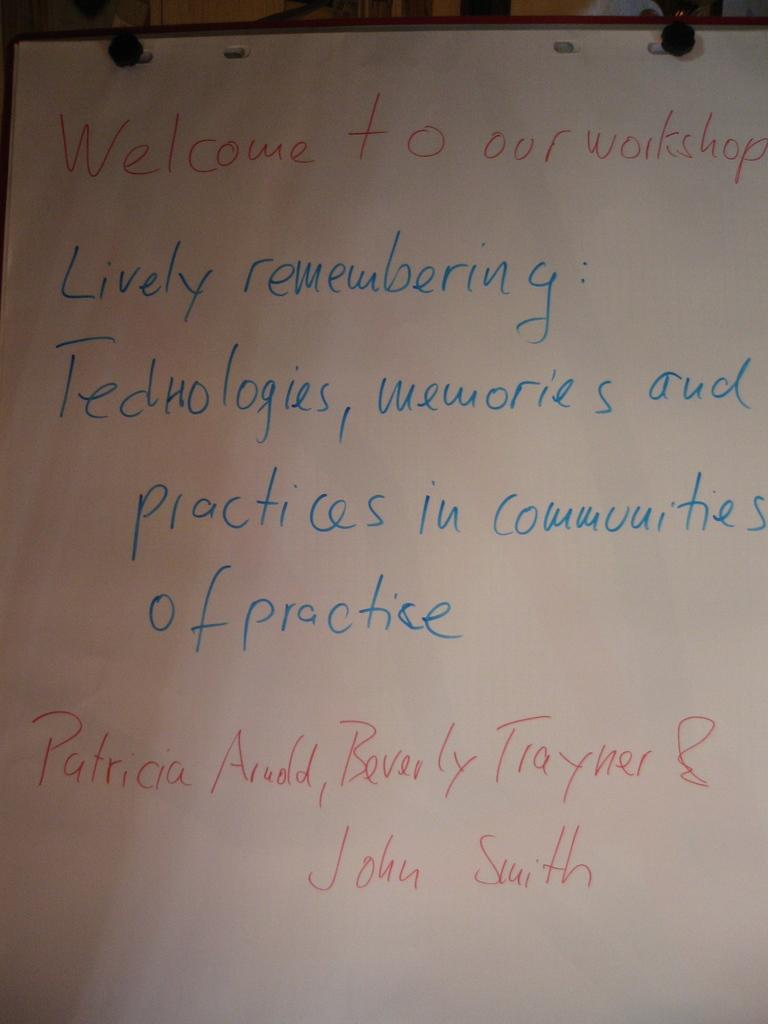<image>
Provide a brief description of the given image. White board with the words "Welcome to our Workshop" in red. 